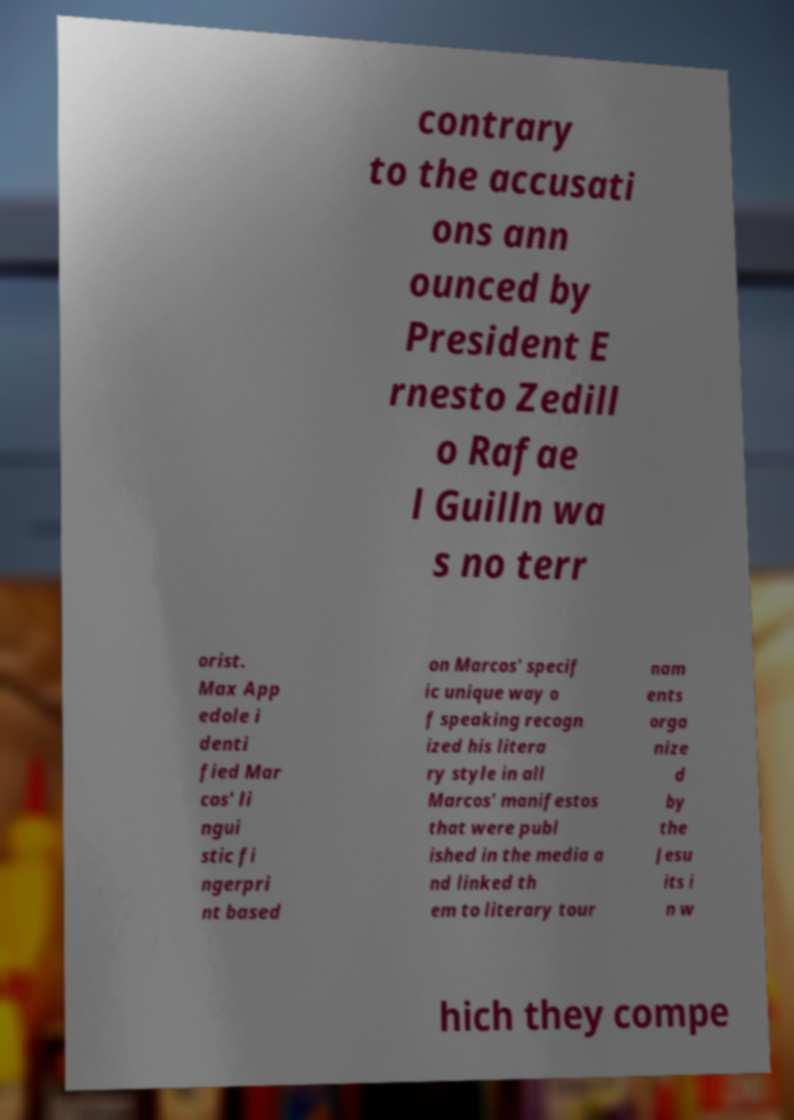Could you assist in decoding the text presented in this image and type it out clearly? contrary to the accusati ons ann ounced by President E rnesto Zedill o Rafae l Guilln wa s no terr orist. Max App edole i denti fied Mar cos' li ngui stic fi ngerpri nt based on Marcos' specif ic unique way o f speaking recogn ized his litera ry style in all Marcos' manifestos that were publ ished in the media a nd linked th em to literary tour nam ents orga nize d by the Jesu its i n w hich they compe 